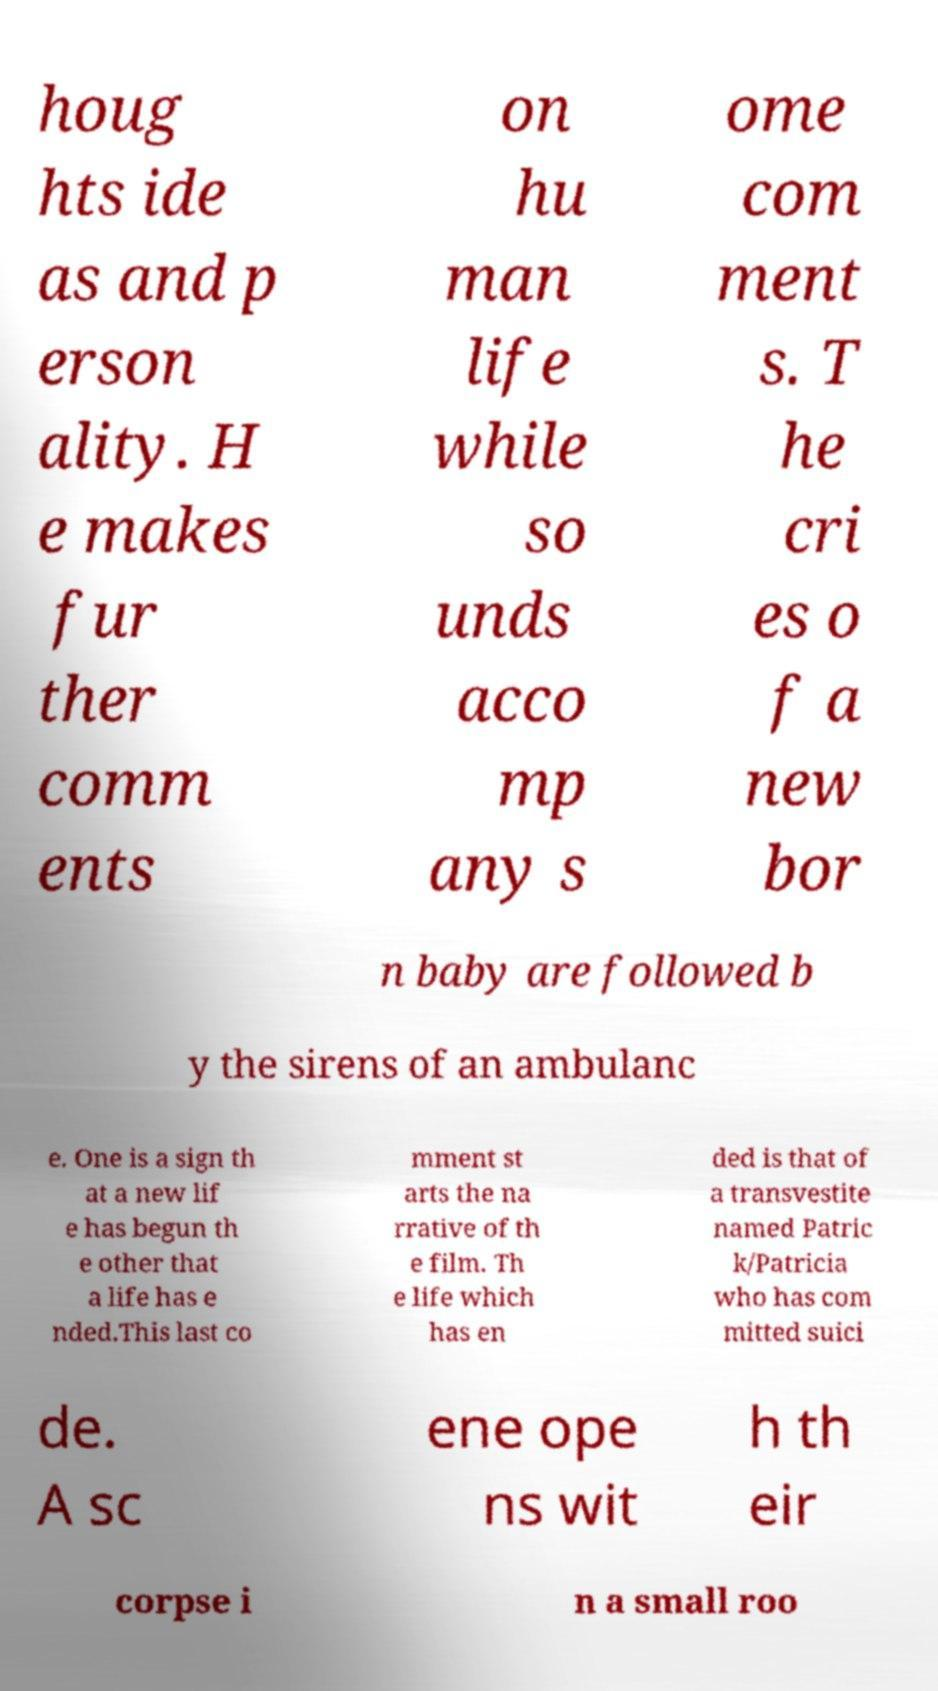Could you extract and type out the text from this image? houg hts ide as and p erson ality. H e makes fur ther comm ents on hu man life while so unds acco mp any s ome com ment s. T he cri es o f a new bor n baby are followed b y the sirens of an ambulanc e. One is a sign th at a new lif e has begun th e other that a life has e nded.This last co mment st arts the na rrative of th e film. Th e life which has en ded is that of a transvestite named Patric k/Patricia who has com mitted suici de. A sc ene ope ns wit h th eir corpse i n a small roo 